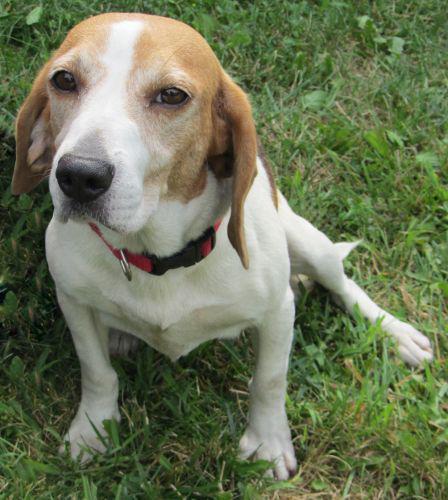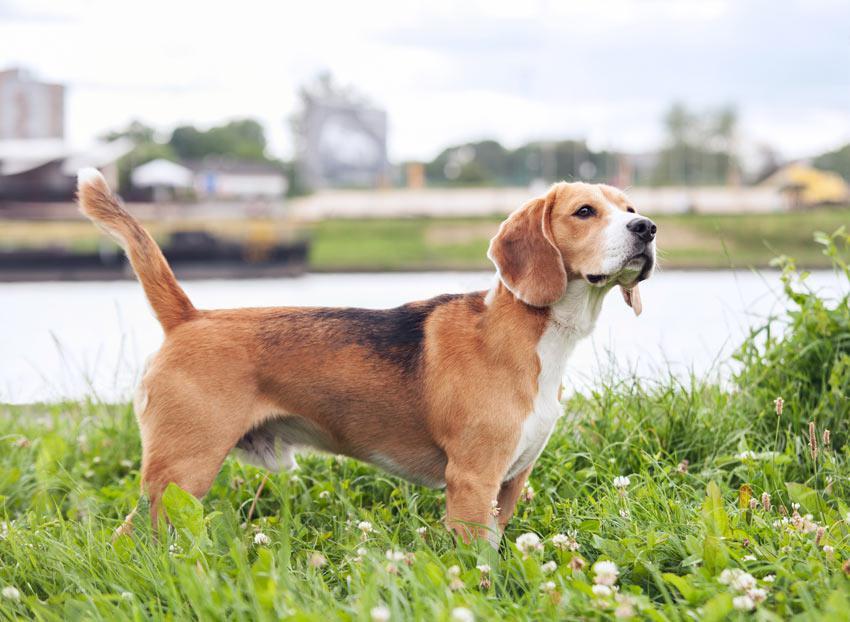The first image is the image on the left, the second image is the image on the right. Analyze the images presented: Is the assertion "There are no more than two dogs." valid? Answer yes or no. Yes. The first image is the image on the left, the second image is the image on the right. For the images displayed, is the sentence "An image includes two tri-color beagles of the same approximate size." factually correct? Answer yes or no. No. 